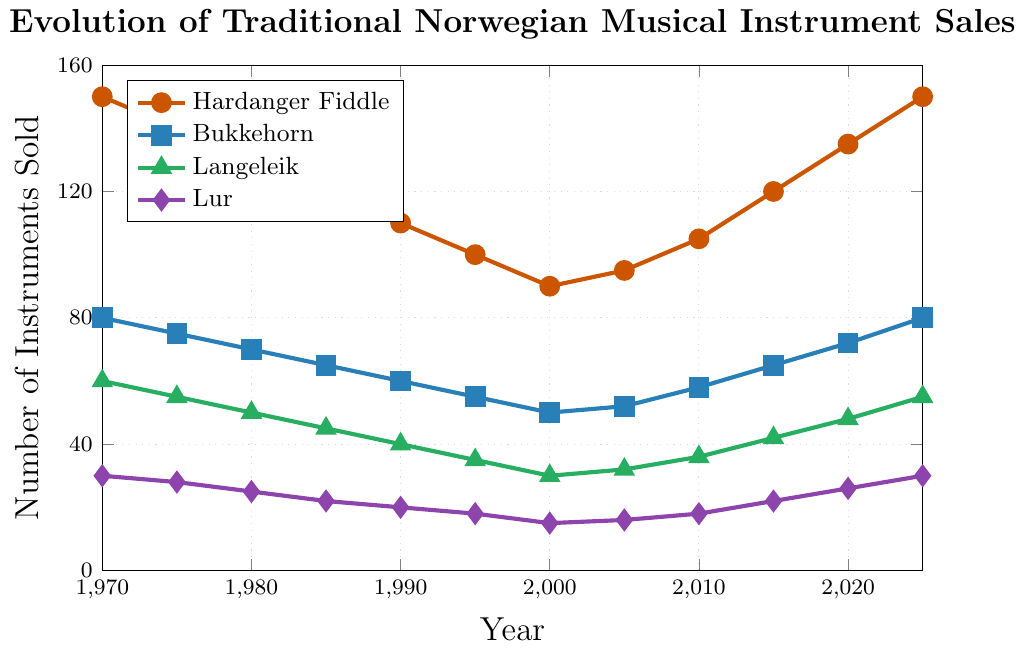How has the sales trend for the Hardanger Fiddle changed from 1970 to 2025? To find the trend, look at the Hardanger Fiddle line. It starts at 150 units in 1970 and decreases steadily until 2000 to 90. From 2005, it starts increasing again, reaching 150 by 2025. This implies a U-shaped trend.
Answer: Decreased until 2000, then increased In which year did the Bukkehorn sales equal Lur sales? To answer this, look for the intersection points of the Bukkehorn and Lur lines on the chart. The sales of both instruments are 30 units in 1970 and will be 30 units again in 2025.
Answer: 1970 and 2025 Compare the sales of Langeleik and Lur in 1990. Which instrument had higher sales? In 1990, the Langeleik had a sales figure of 40 units, and the Lur had 20 units. Comparing these two, Langeleik had higher sales.
Answer: Langeleik What is the sum of the sales of all four instruments in 1985? For 1985, sum the sales of Hardanger Fiddle (120), Bukkehorn (65), Langeleik (45), and Lur (22). The calculation is 120 + 65 + 45 + 22 = 252.
Answer: 252 Which instrument showed the most significant increase in sales from 2000 to 2025? Calculate the difference for each instrument between 2000 and 2025: Hardanger Fiddle increased by 60 (150-90), Bukkehorn by 30 (80-50), Langeleik by 25 (55-30), and Lur by 15 (30-15). The Hardanger Fiddle showed the largest increase.
Answer: Hardanger Fiddle Describe the visual representation of sales for the Lur from 1970 to 2025. The Lur line starts at 30 units in 1970, decreases slightly to 15 units in 2000, then gradually increases back to 30 units by 2025.
Answer: Decreased, then increased back to the starting value What is the range of sales values for Hardanger Fiddle over the period shown? The highest sales value for Hardanger Fiddle is 150 units (1970 and 2025), and the lowest is 90 units (2000). Thus, the range is 150 - 90 = 60 units.
Answer: 60 How do the sales trends of the Bukkehorn and Langeleik compare from 2000 to 2025? From 2000 to 2025, Bukkehorn sales increase from 50 to 80 units, which is a steady rise. Langeleik sales increase from 30 to 55 units, also showing a steady rise. Both instruments demonstrate a similar increasing trend.
Answer: Both increased steadily 